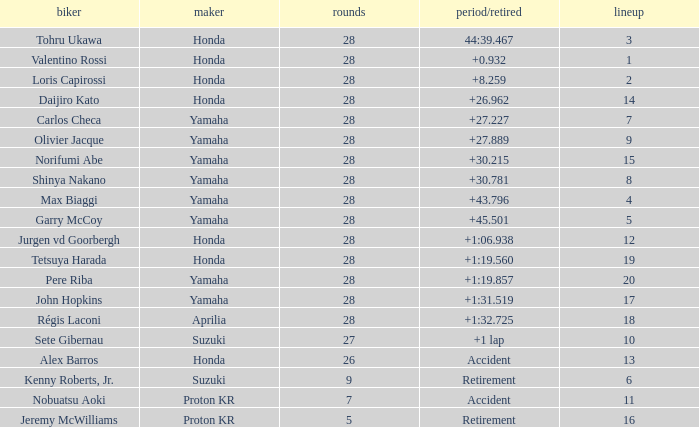Who manufactured grid 11? Proton KR. 